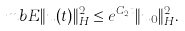Convert formula to latex. <formula><loc_0><loc_0><loc_500><loc_500>\ m b E \| u ( t ) \| _ { H } ^ { 2 } \leq e ^ { C _ { 2 } t } \| u _ { 0 } \| _ { H } ^ { 2 } .</formula> 